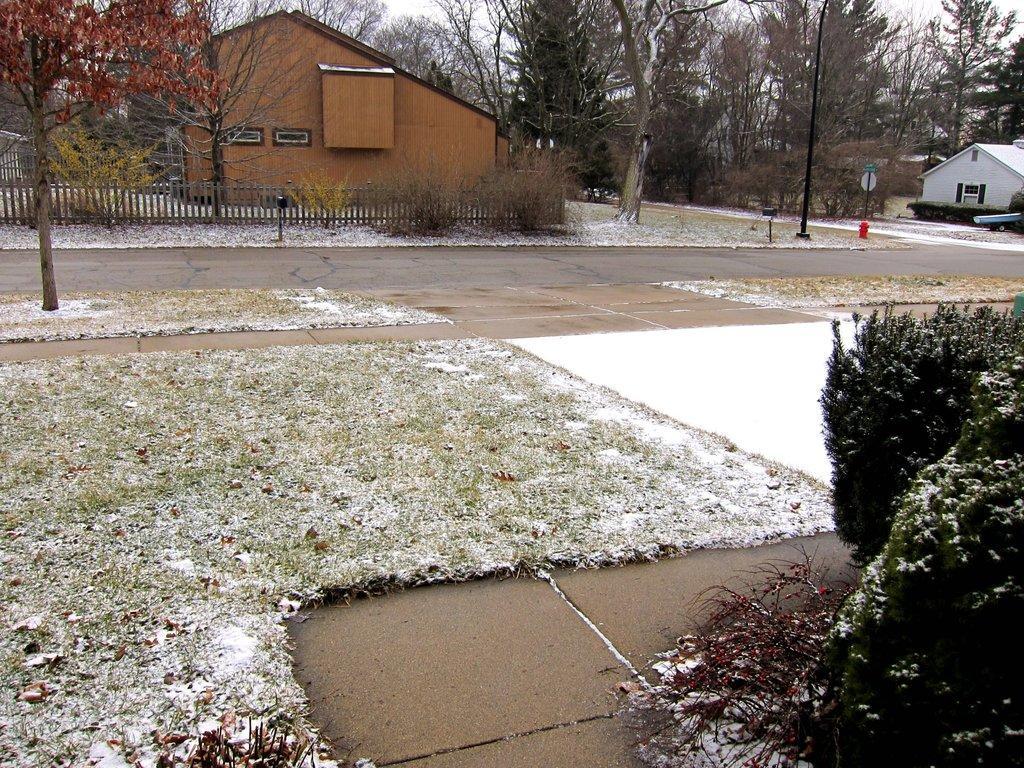How would you summarize this image in a sentence or two? This picture is clicked outside. In the center we can see the grass, plants, trees, fence, metal rods and houses. In the background we can see the trees and the sky and some other objects. 